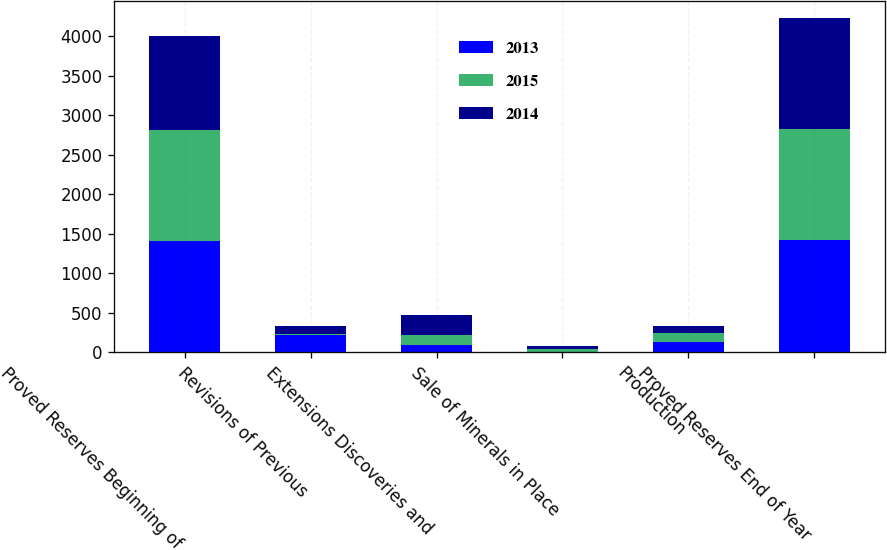<chart> <loc_0><loc_0><loc_500><loc_500><stacked_bar_chart><ecel><fcel>Proved Reserves Beginning of<fcel>Revisions of Previous<fcel>Extensions Discoveries and<fcel>Sale of Minerals in Place<fcel>Production<fcel>Proved Reserves End of Year<nl><fcel>2013<fcel>1404<fcel>216<fcel>100<fcel>6<fcel>130<fcel>1421<nl><fcel>2015<fcel>1406<fcel>21<fcel>120<fcel>33<fcel>110<fcel>1404<nl><fcel>2014<fcel>1184<fcel>95<fcel>250<fcel>47<fcel>100<fcel>1406<nl></chart> 